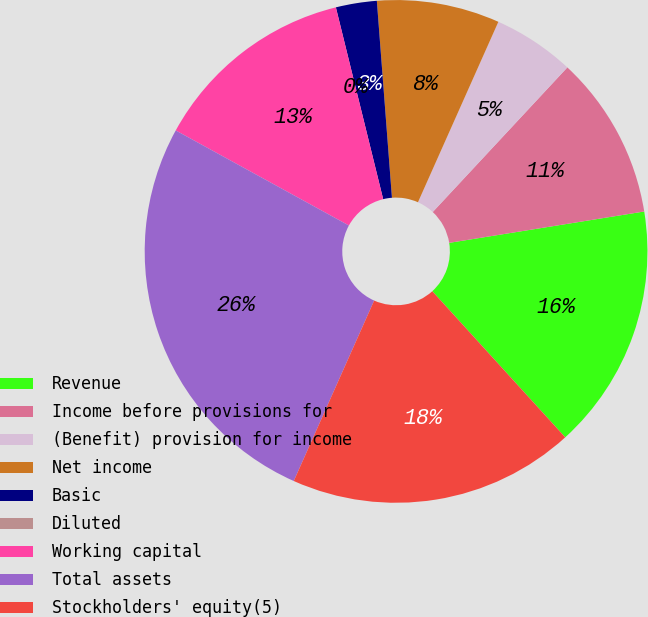Convert chart. <chart><loc_0><loc_0><loc_500><loc_500><pie_chart><fcel>Revenue<fcel>Income before provisions for<fcel>(Benefit) provision for income<fcel>Net income<fcel>Basic<fcel>Diluted<fcel>Working capital<fcel>Total assets<fcel>Stockholders' equity(5)<nl><fcel>15.79%<fcel>10.53%<fcel>5.26%<fcel>7.89%<fcel>2.63%<fcel>0.0%<fcel>13.16%<fcel>26.32%<fcel>18.42%<nl></chart> 